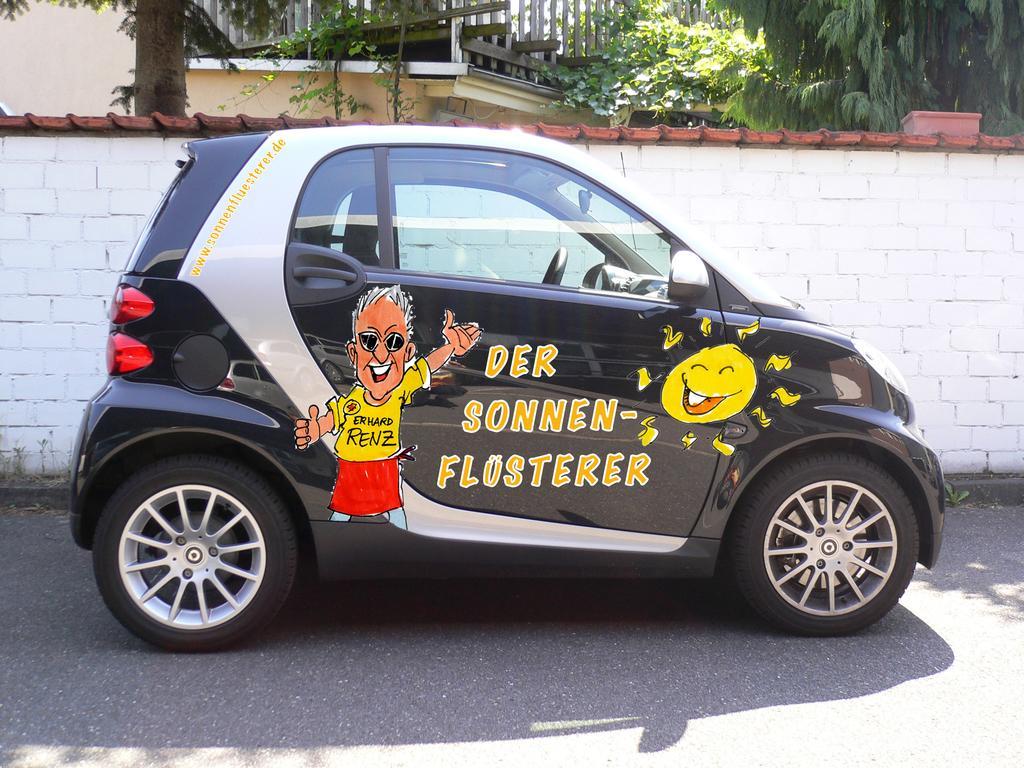In one or two sentences, can you explain what this image depicts? It's a car which is in black color and there are cartoon pics on it. This is a brick wall which is in white color. There are trees in the back side of an image. 